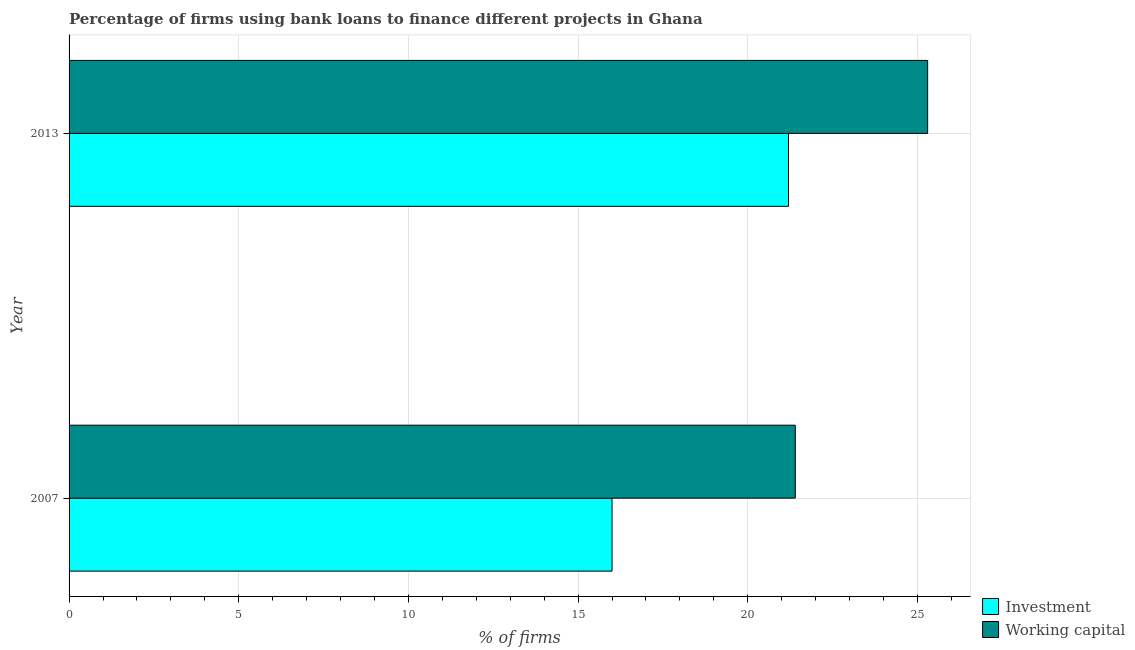How many groups of bars are there?
Offer a very short reply. 2. What is the label of the 2nd group of bars from the top?
Give a very brief answer. 2007. What is the percentage of firms using banks to finance working capital in 2013?
Offer a terse response. 25.3. Across all years, what is the maximum percentage of firms using banks to finance working capital?
Offer a terse response. 25.3. Across all years, what is the minimum percentage of firms using banks to finance working capital?
Provide a short and direct response. 21.4. What is the total percentage of firms using banks to finance working capital in the graph?
Your response must be concise. 46.7. What is the difference between the percentage of firms using banks to finance working capital in 2007 and the percentage of firms using banks to finance investment in 2013?
Your answer should be very brief. 0.2. What is the average percentage of firms using banks to finance working capital per year?
Provide a succinct answer. 23.35. In how many years, is the percentage of firms using banks to finance working capital greater than 18 %?
Offer a very short reply. 2. What is the ratio of the percentage of firms using banks to finance working capital in 2007 to that in 2013?
Offer a very short reply. 0.85. What does the 2nd bar from the top in 2013 represents?
Provide a short and direct response. Investment. What does the 1st bar from the bottom in 2007 represents?
Your response must be concise. Investment. What is the difference between two consecutive major ticks on the X-axis?
Make the answer very short. 5. Does the graph contain any zero values?
Offer a terse response. No. Where does the legend appear in the graph?
Offer a terse response. Bottom right. How many legend labels are there?
Provide a succinct answer. 2. How are the legend labels stacked?
Your answer should be very brief. Vertical. What is the title of the graph?
Your answer should be very brief. Percentage of firms using bank loans to finance different projects in Ghana. Does "Research and Development" appear as one of the legend labels in the graph?
Give a very brief answer. No. What is the label or title of the X-axis?
Offer a very short reply. % of firms. What is the % of firms in Working capital in 2007?
Ensure brevity in your answer.  21.4. What is the % of firms in Investment in 2013?
Your response must be concise. 21.2. What is the % of firms in Working capital in 2013?
Make the answer very short. 25.3. Across all years, what is the maximum % of firms in Investment?
Provide a short and direct response. 21.2. Across all years, what is the maximum % of firms in Working capital?
Ensure brevity in your answer.  25.3. Across all years, what is the minimum % of firms of Working capital?
Give a very brief answer. 21.4. What is the total % of firms in Investment in the graph?
Ensure brevity in your answer.  37.2. What is the total % of firms of Working capital in the graph?
Make the answer very short. 46.7. What is the difference between the % of firms of Working capital in 2007 and that in 2013?
Provide a succinct answer. -3.9. What is the average % of firms in Investment per year?
Your answer should be compact. 18.6. What is the average % of firms of Working capital per year?
Provide a succinct answer. 23.35. In the year 2013, what is the difference between the % of firms in Investment and % of firms in Working capital?
Keep it short and to the point. -4.1. What is the ratio of the % of firms in Investment in 2007 to that in 2013?
Offer a very short reply. 0.75. What is the ratio of the % of firms in Working capital in 2007 to that in 2013?
Offer a terse response. 0.85. What is the difference between the highest and the second highest % of firms of Investment?
Your answer should be compact. 5.2. What is the difference between the highest and the second highest % of firms of Working capital?
Your response must be concise. 3.9. What is the difference between the highest and the lowest % of firms of Investment?
Offer a terse response. 5.2. What is the difference between the highest and the lowest % of firms of Working capital?
Ensure brevity in your answer.  3.9. 